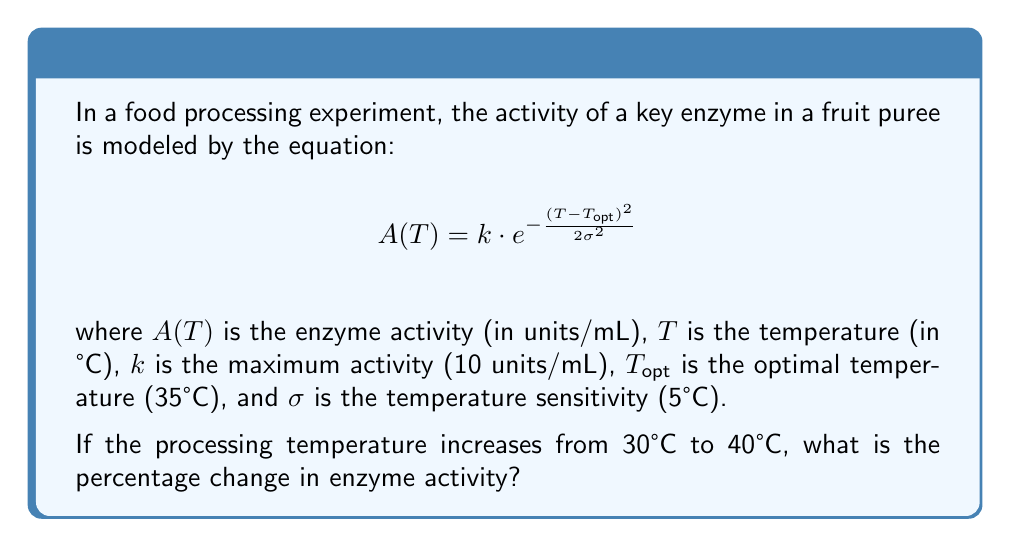Give your solution to this math problem. To solve this problem, we need to follow these steps:

1) Calculate the enzyme activity at 30°C:
   $$A(30) = 10 \cdot e^{-\frac{(30-35)^2}{2(5)^2}}$$
   $$= 10 \cdot e^{-\frac{25}{50}} = 10 \cdot e^{-0.5} = 10 \cdot 0.6065 = 6.065 \text{ units/mL}$$

2) Calculate the enzyme activity at 40°C:
   $$A(40) = 10 \cdot e^{-\frac{(40-35)^2}{2(5)^2}}$$
   $$= 10 \cdot e^{-\frac{25}{50}} = 10 \cdot e^{-0.5} = 10 \cdot 0.6065 = 6.065 \text{ units/mL}$$

3) Calculate the percentage change:
   Percentage change = $\frac{\text{Change in value}}{\text{Original value}} \times 100\%$
   $$= \frac{A(40) - A(30)}{A(30)} \times 100\%$$
   $$= \frac{6.065 - 6.065}{6.065} \times 100\% = 0\%$$

The enzyme activity remains the same when the temperature increases from 30°C to 40°C because these temperatures are equidistant from the optimal temperature (35°C) in this symmetric model.
Answer: 0% 